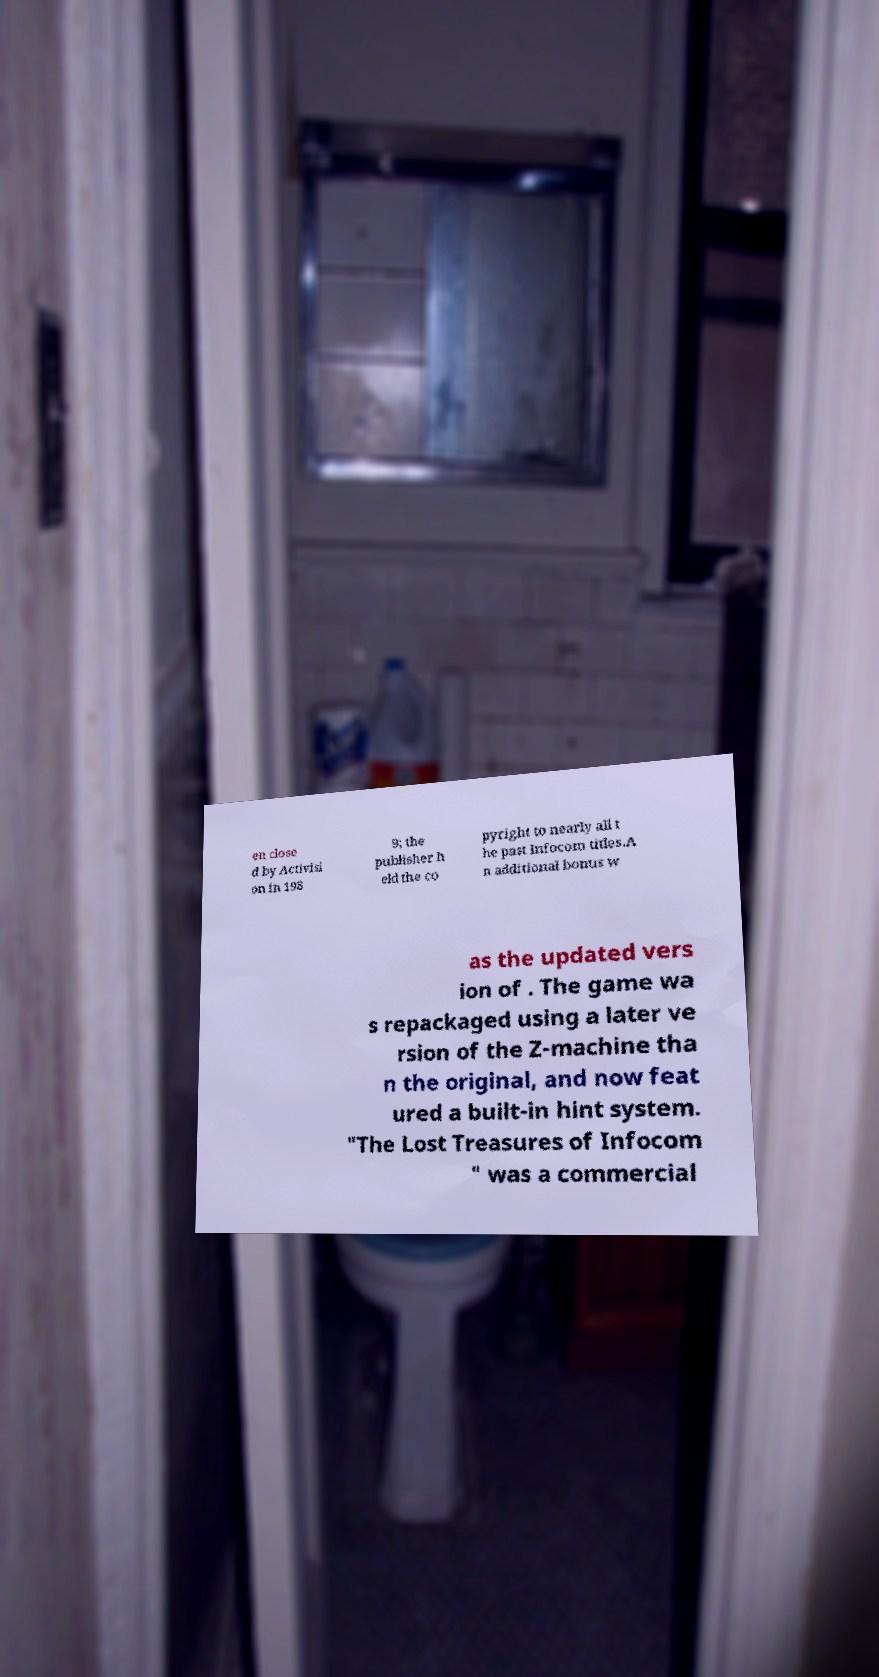Can you accurately transcribe the text from the provided image for me? en close d by Activisi on in 198 9; the publisher h eld the co pyright to nearly all t he past Infocom titles.A n additional bonus w as the updated vers ion of . The game wa s repackaged using a later ve rsion of the Z-machine tha n the original, and now feat ured a built-in hint system. "The Lost Treasures of Infocom " was a commercial 